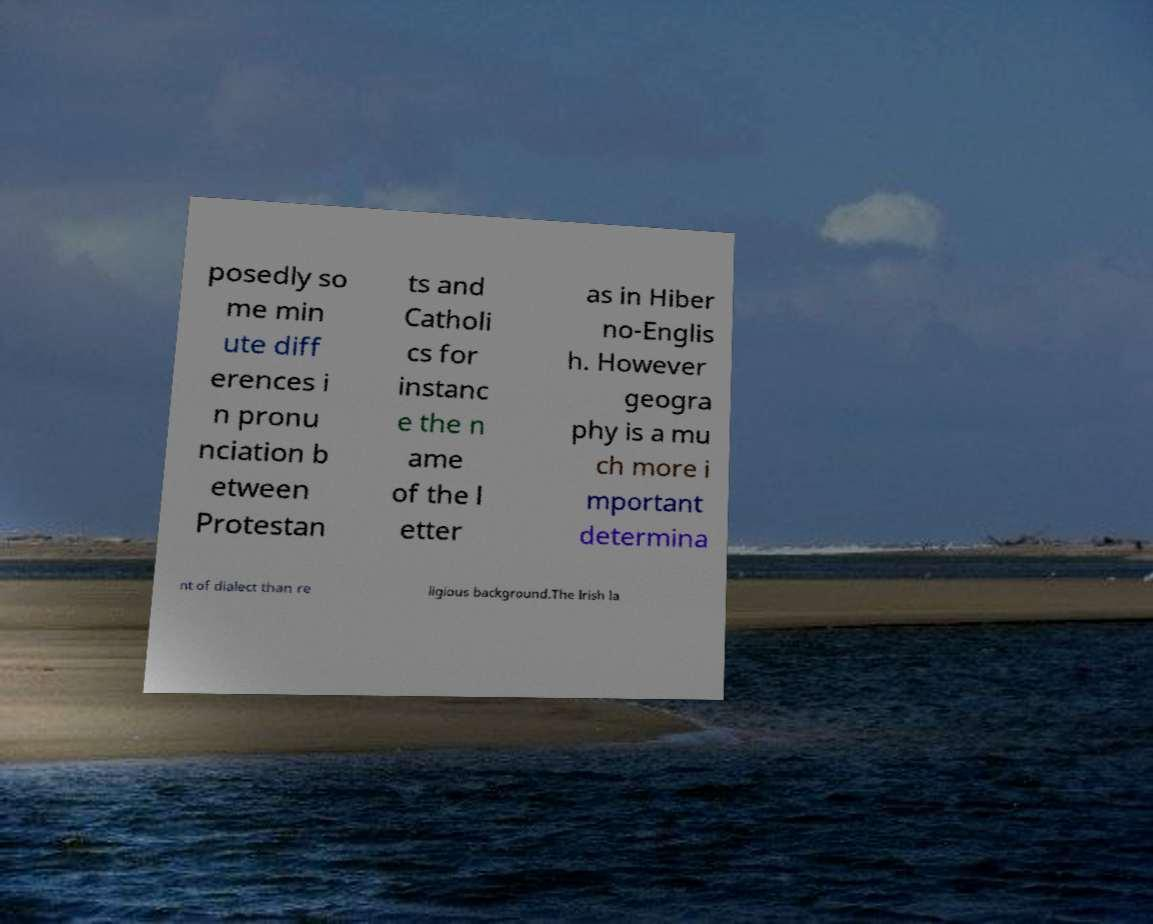Can you accurately transcribe the text from the provided image for me? posedly so me min ute diff erences i n pronu nciation b etween Protestan ts and Catholi cs for instanc e the n ame of the l etter as in Hiber no-Englis h. However geogra phy is a mu ch more i mportant determina nt of dialect than re ligious background.The Irish la 